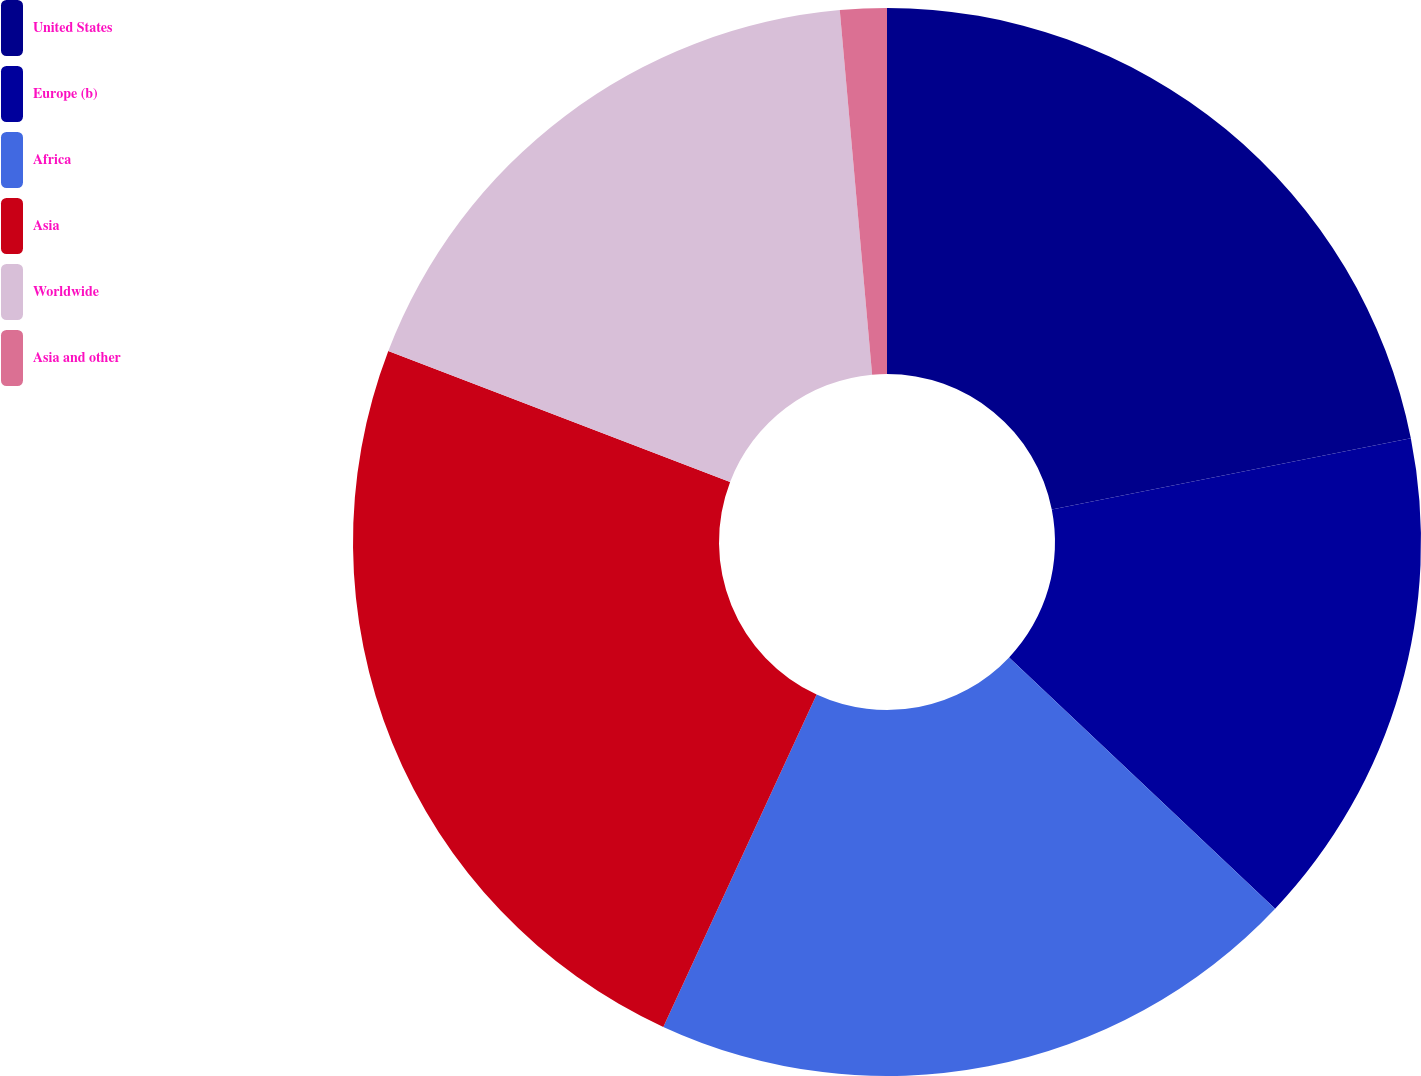<chart> <loc_0><loc_0><loc_500><loc_500><pie_chart><fcel>United States<fcel>Europe (b)<fcel>Africa<fcel>Asia<fcel>Worldwide<fcel>Asia and other<nl><fcel>21.89%<fcel>15.16%<fcel>19.83%<fcel>23.94%<fcel>17.77%<fcel>1.41%<nl></chart> 